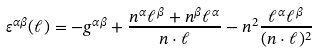<formula> <loc_0><loc_0><loc_500><loc_500>\varepsilon ^ { \alpha \beta } ( \ell ) = - g ^ { \alpha \beta } + \frac { n ^ { \alpha } \ell ^ { \beta } + n ^ { \beta } \ell ^ { \alpha } } { n \cdot \ell } - n ^ { 2 } \frac { \ell ^ { \alpha } \ell ^ { \beta } } { ( n \cdot \ell ) ^ { 2 } }</formula> 